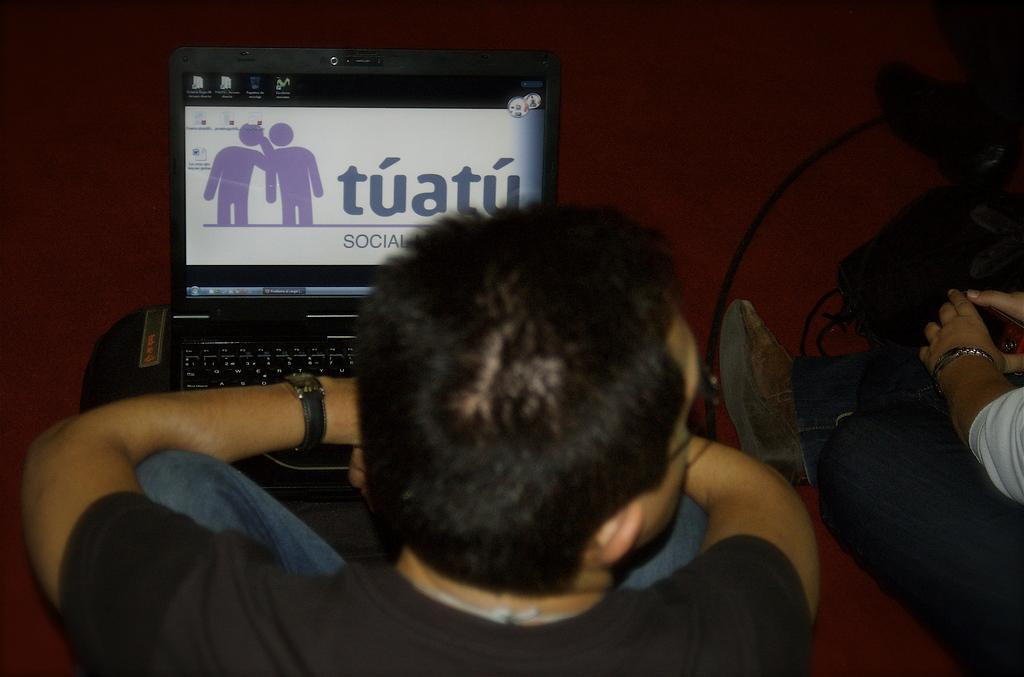<image>
Provide a brief description of the given image. An open laptop says tuatu next to to purple figures. 